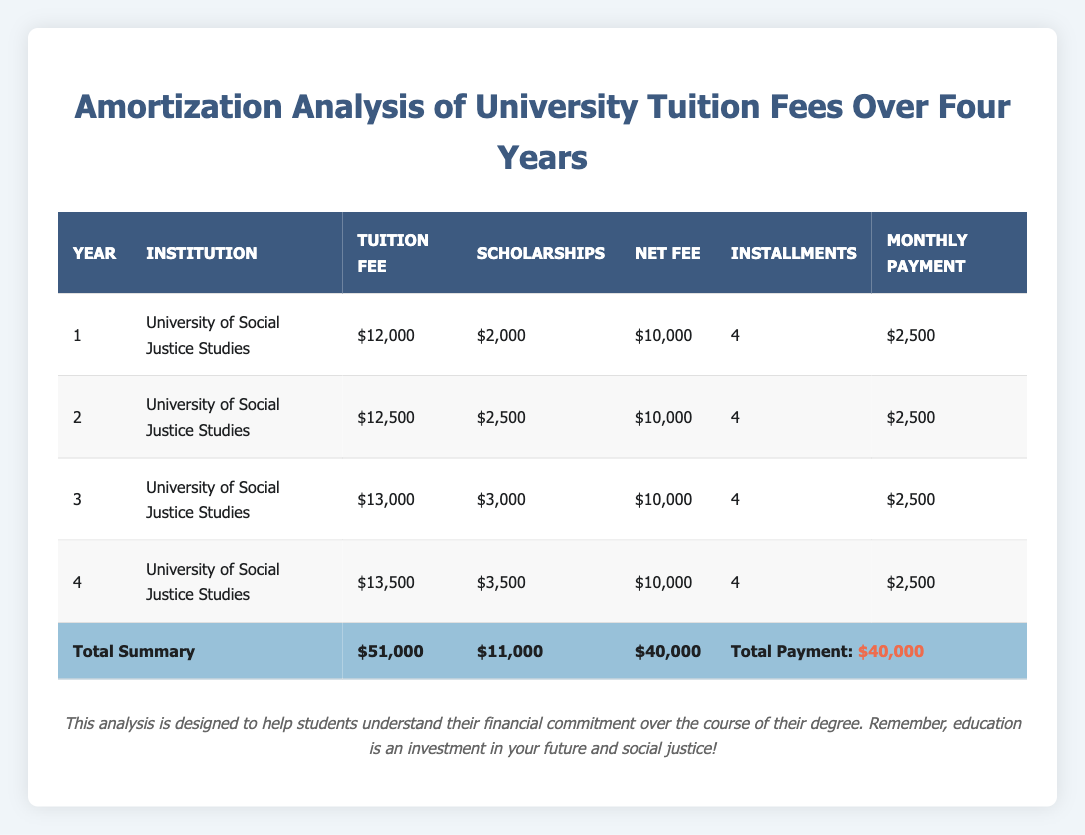What is the total tuition fee for the four years? The table lists the tuition fees for each year as follows: Year 1: 12000, Year 2: 12500, Year 3: 13000, Year 4: 13500. By adding these amounts together (12000 + 12500 + 13000 + 13500), the total tuition fee is 51000.
Answer: 51000 How much in scholarships did the student receive over the four years? The scholarships received per year are: Year 1: 2000, Year 2: 2500, Year 3: 3000, Year 4: 3500. Adding these amounts gives: 2000 + 2500 + 3000 + 3500 = 11000. Thus, the total scholarships amount to 11000.
Answer: 11000 Is the net fee the same for each year? The net fee is listed as 10000 for each year in the table, confirming that it is constant across all four years.
Answer: Yes What is the average monthly payment for the tuition fees? The monthly payment each year is 2500, and since there are four years, we calculate the average as (2500 * 4) / 4 = 2500. Thus, the average monthly payment remains 2500.
Answer: 2500 During which year did the tuition fee increase the most? The increases in tuition fees are as follows: Year 1 to Year 2: 500, Year 2 to Year 3: 500, Year 3 to Year 4: 500. Each increase is the same, so the largest change is 500, occurring uniformly each year.
Answer: Same increase each year (500) What is the total net fee paid over the four years? The net fee for each year is consistently reported as 10000, and since this occurs for four years, the total is calculated as 10000 * 4 = 40000.
Answer: 40000 Is the student paying more in tuition fees in year four compared to year one? The tuition fee in year four is stated to be 13500 whereas in year one it is 12000. Comparing these amounts shows that 13500 is greater than 12000, indicating an increase.
Answer: Yes How much more is the tuition fee in year four compared to its scholarship amount for that year? The tuition fee for year four is 13500 and the scholarship amount for that year is 3500. Subtracting the scholarship from the tuition yields: 13500 - 3500 = 10000. Therefore, the difference is 10000.
Answer: 10000 